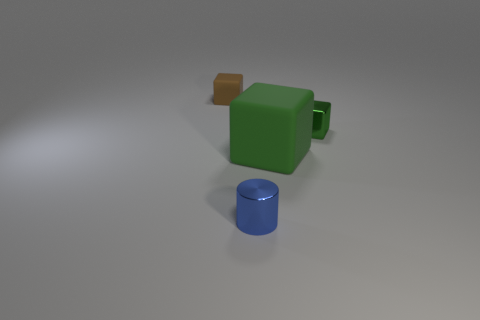Subtract all green blocks. How many were subtracted if there are1green blocks left? 1 Subtract all small brown cubes. How many cubes are left? 2 Subtract all yellow spheres. How many green cubes are left? 2 Add 4 small green things. How many objects exist? 8 Add 4 small green rubber spheres. How many small green rubber spheres exist? 4 Subtract 0 blue balls. How many objects are left? 4 Subtract all blocks. How many objects are left? 1 Subtract all red cubes. Subtract all gray balls. How many cubes are left? 3 Subtract all big purple matte cylinders. Subtract all big rubber things. How many objects are left? 3 Add 2 tiny blue metal cylinders. How many tiny blue metal cylinders are left? 3 